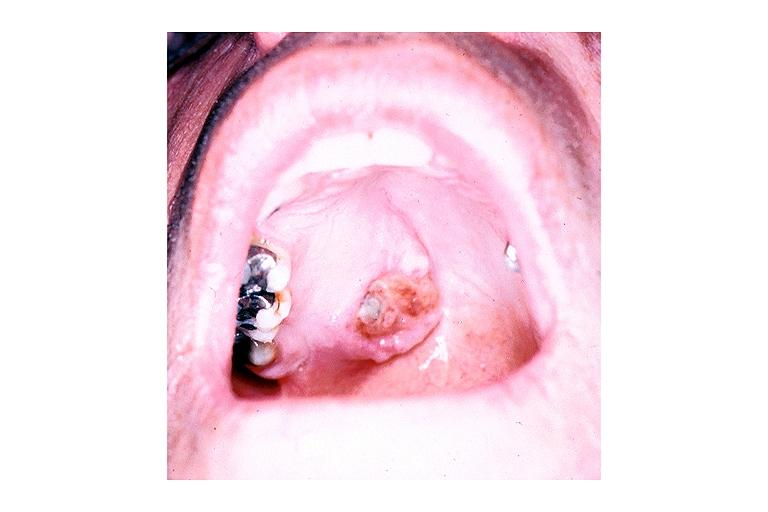what does this image show?
Answer the question using a single word or phrase. Adenoid cystic carcinoma 